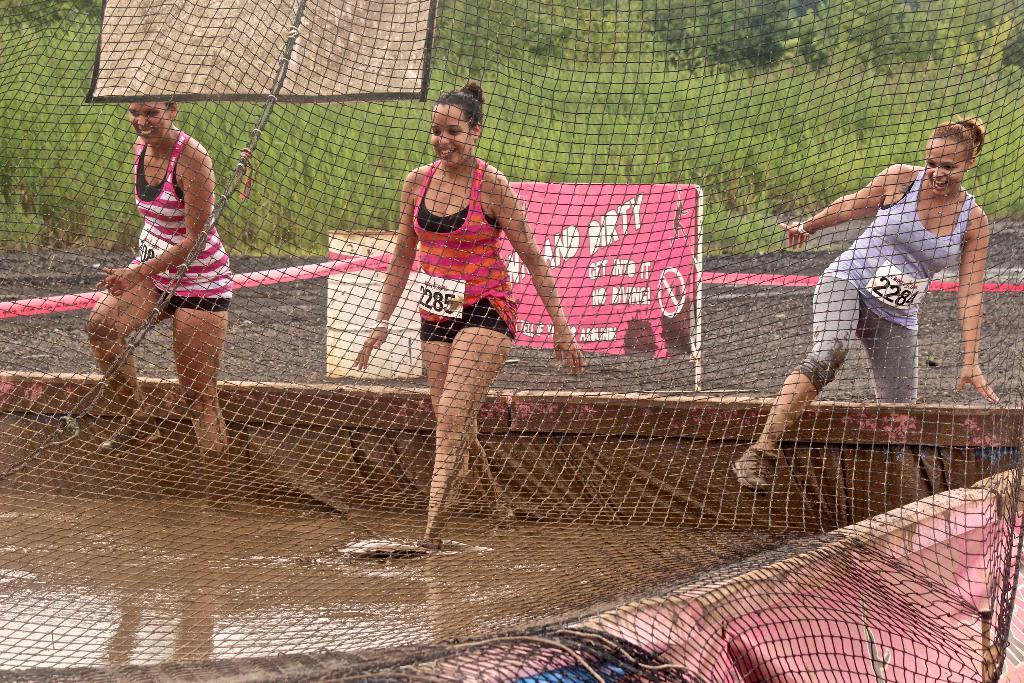<image>
Relay a brief, clear account of the picture shown. The girl wearing number 2285 is entering a muddy pool of water with two other girls. 